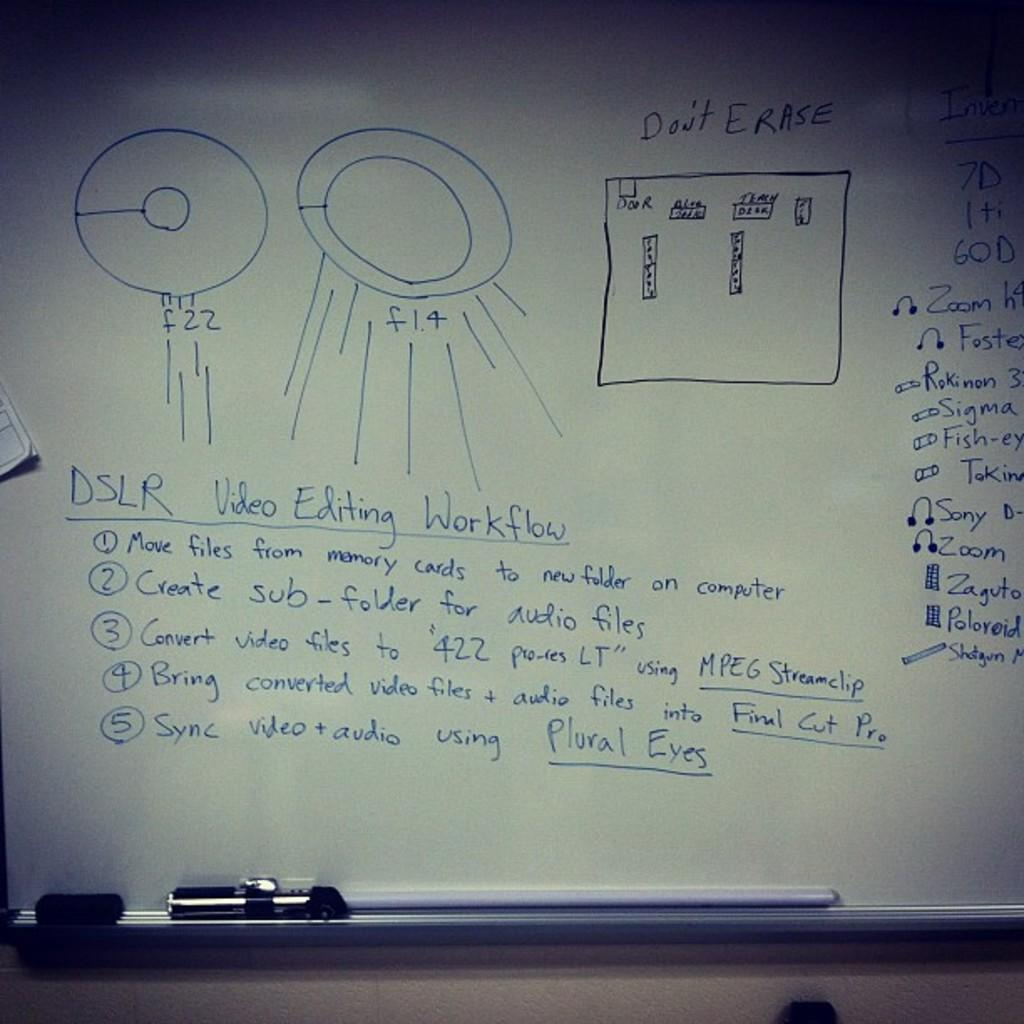Provide a one-sentence caption for the provided image. Notes written on a whiteboard about DSLR Video Editing Workflow. 